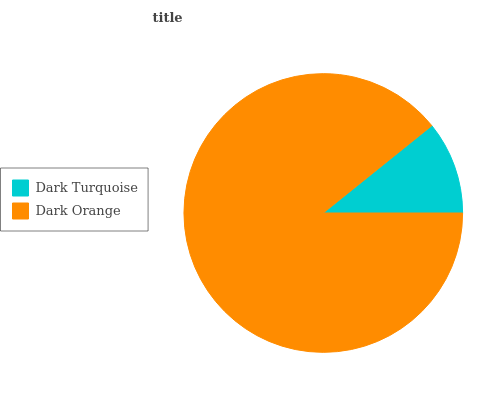Is Dark Turquoise the minimum?
Answer yes or no. Yes. Is Dark Orange the maximum?
Answer yes or no. Yes. Is Dark Orange the minimum?
Answer yes or no. No. Is Dark Orange greater than Dark Turquoise?
Answer yes or no. Yes. Is Dark Turquoise less than Dark Orange?
Answer yes or no. Yes. Is Dark Turquoise greater than Dark Orange?
Answer yes or no. No. Is Dark Orange less than Dark Turquoise?
Answer yes or no. No. Is Dark Orange the high median?
Answer yes or no. Yes. Is Dark Turquoise the low median?
Answer yes or no. Yes. Is Dark Turquoise the high median?
Answer yes or no. No. Is Dark Orange the low median?
Answer yes or no. No. 